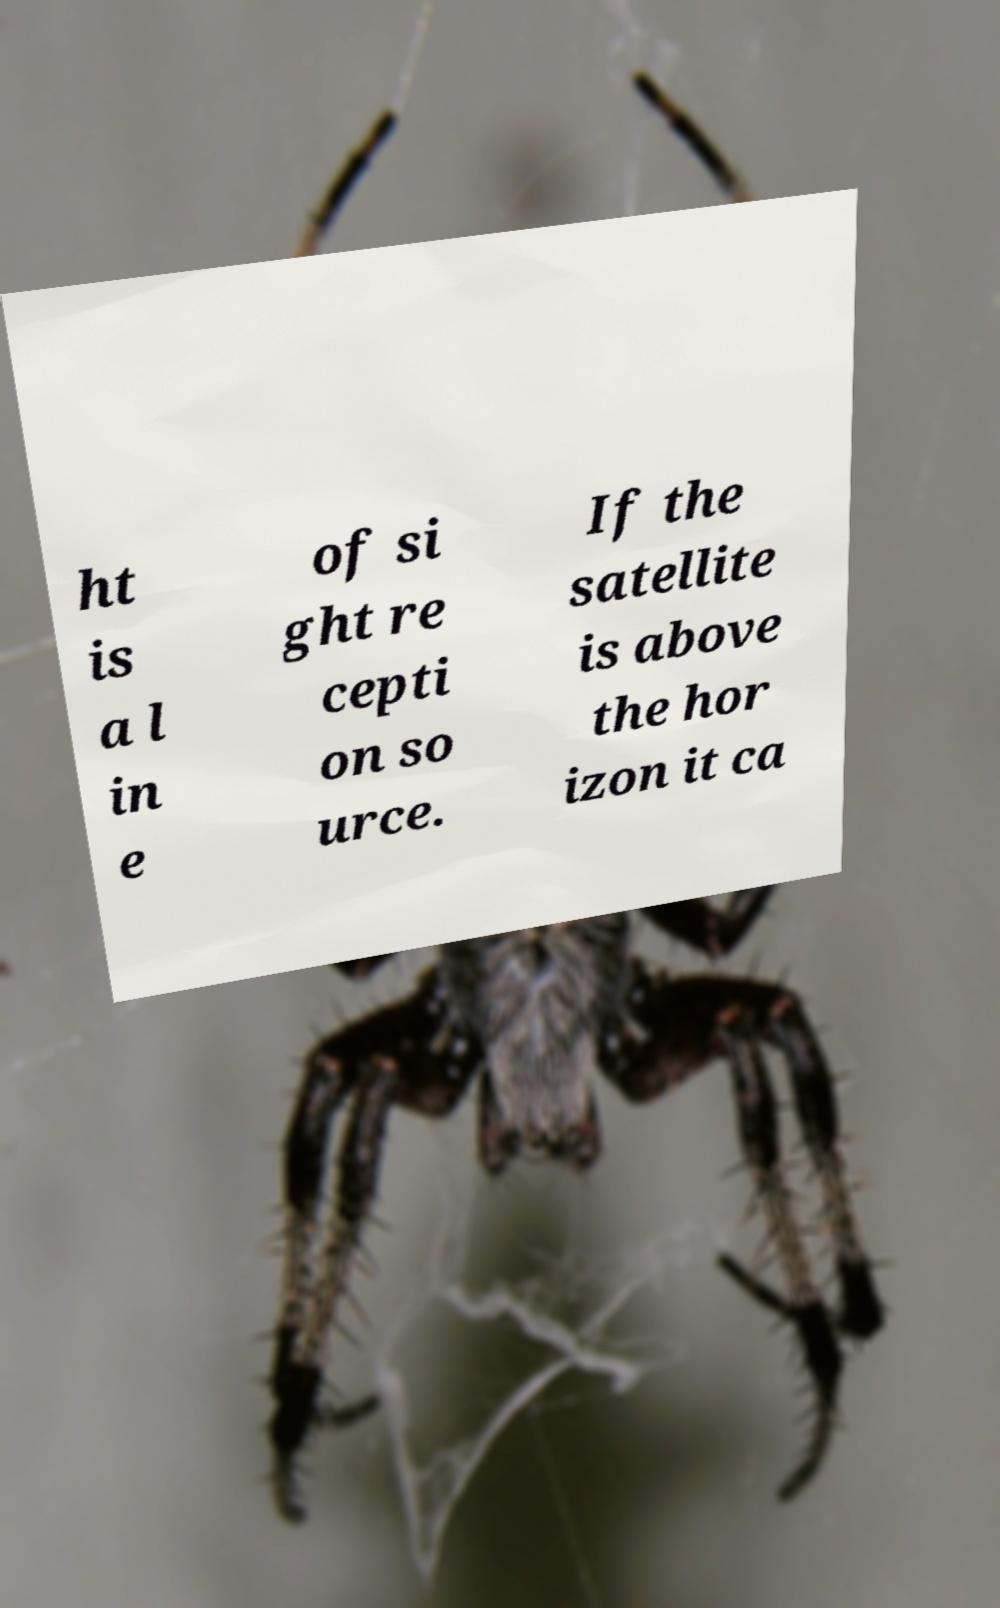Can you read and provide the text displayed in the image?This photo seems to have some interesting text. Can you extract and type it out for me? ht is a l in e of si ght re cepti on so urce. If the satellite is above the hor izon it ca 